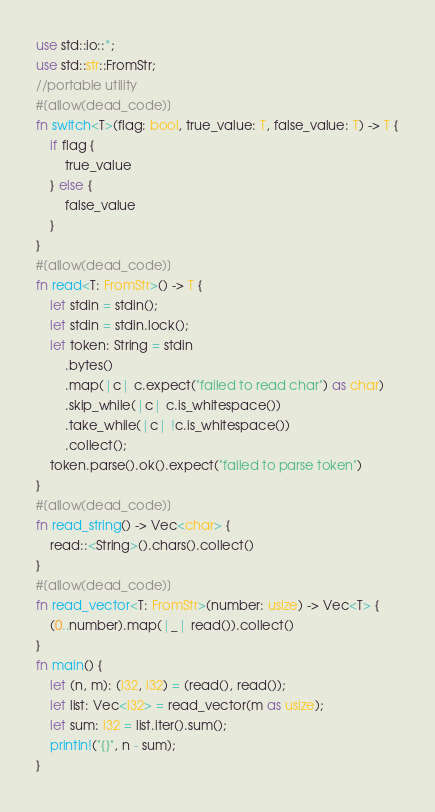Convert code to text. <code><loc_0><loc_0><loc_500><loc_500><_Rust_>use std::io::*;
use std::str::FromStr;
//portable utility
#[allow(dead_code)]
fn switch<T>(flag: bool, true_value: T, false_value: T) -> T {
    if flag {
        true_value
    } else {
        false_value
    }
}
#[allow(dead_code)]
fn read<T: FromStr>() -> T {
    let stdin = stdin();
    let stdin = stdin.lock();
    let token: String = stdin
        .bytes()
        .map(|c| c.expect("failed to read char") as char)
        .skip_while(|c| c.is_whitespace())
        .take_while(|c| !c.is_whitespace())
        .collect();
    token.parse().ok().expect("failed to parse token")
}
#[allow(dead_code)]
fn read_string() -> Vec<char> {
    read::<String>().chars().collect()
}
#[allow(dead_code)]
fn read_vector<T: FromStr>(number: usize) -> Vec<T> {
    (0..number).map(|_| read()).collect()
}
fn main() {
    let (n, m): (i32, i32) = (read(), read());
    let list: Vec<i32> = read_vector(m as usize);
    let sum: i32 = list.iter().sum();
    println!("{}", n - sum);
}
</code> 